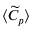<formula> <loc_0><loc_0><loc_500><loc_500>\langle \widetilde { C } _ { p } \rangle</formula> 